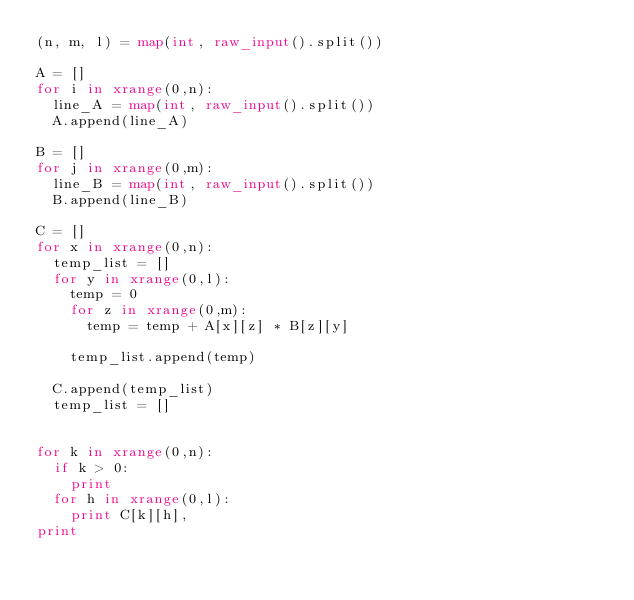<code> <loc_0><loc_0><loc_500><loc_500><_Python_>(n, m, l) = map(int, raw_input().split())

A = []
for i in xrange(0,n):
	line_A = map(int, raw_input().split())
	A.append(line_A)

B = []
for j in xrange(0,m):
	line_B = map(int, raw_input().split())
	B.append(line_B)

C = []
for x in xrange(0,n):
	temp_list = []
	for y in xrange(0,l):
		temp = 0
		for z in xrange(0,m):
			temp = temp + A[x][z] * B[z][y]

		temp_list.append(temp)
		
	C.append(temp_list)
	temp_list = []
			

for k in xrange(0,n):
	if k > 0:
		print
	for h in xrange(0,l):
		print C[k][h],
print</code> 